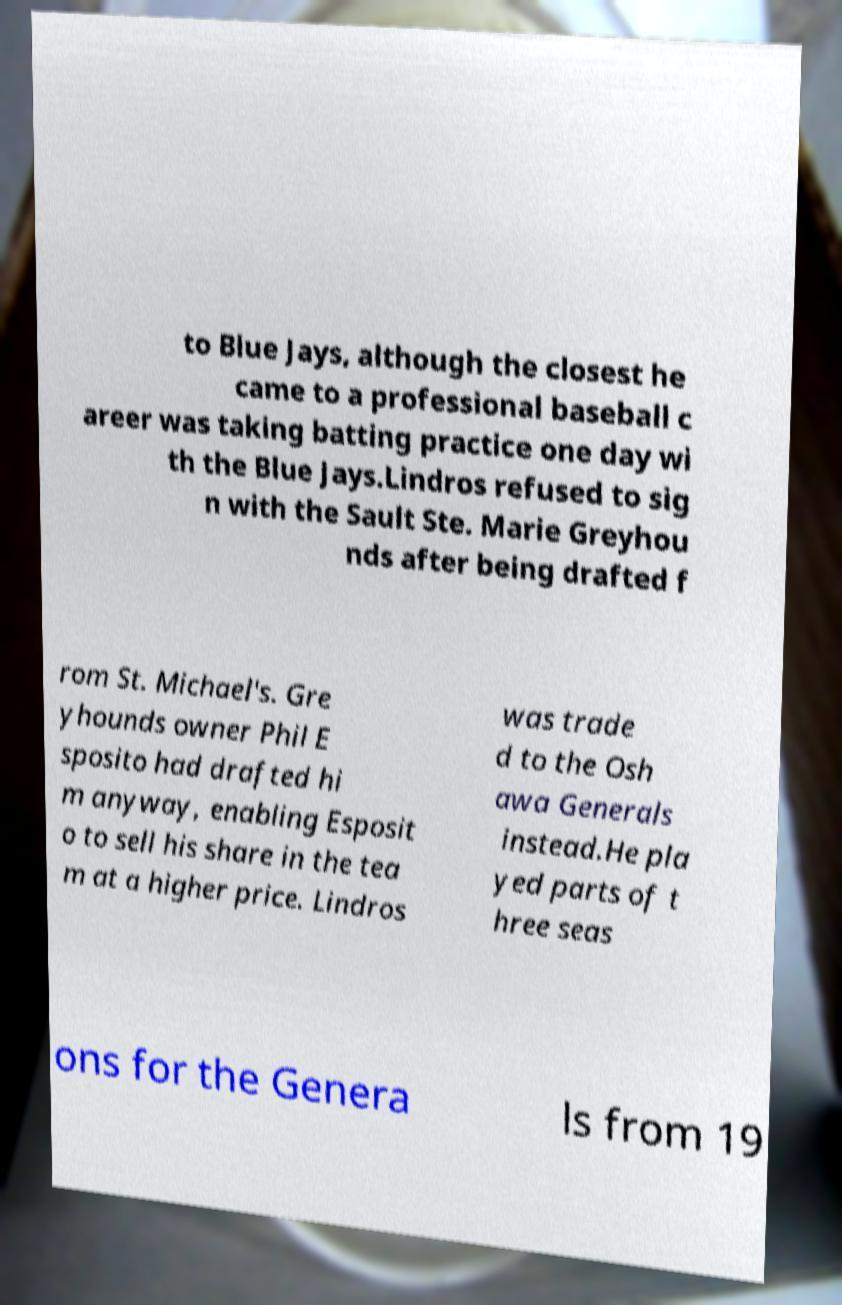Can you accurately transcribe the text from the provided image for me? to Blue Jays, although the closest he came to a professional baseball c areer was taking batting practice one day wi th the Blue Jays.Lindros refused to sig n with the Sault Ste. Marie Greyhou nds after being drafted f rom St. Michael's. Gre yhounds owner Phil E sposito had drafted hi m anyway, enabling Esposit o to sell his share in the tea m at a higher price. Lindros was trade d to the Osh awa Generals instead.He pla yed parts of t hree seas ons for the Genera ls from 19 